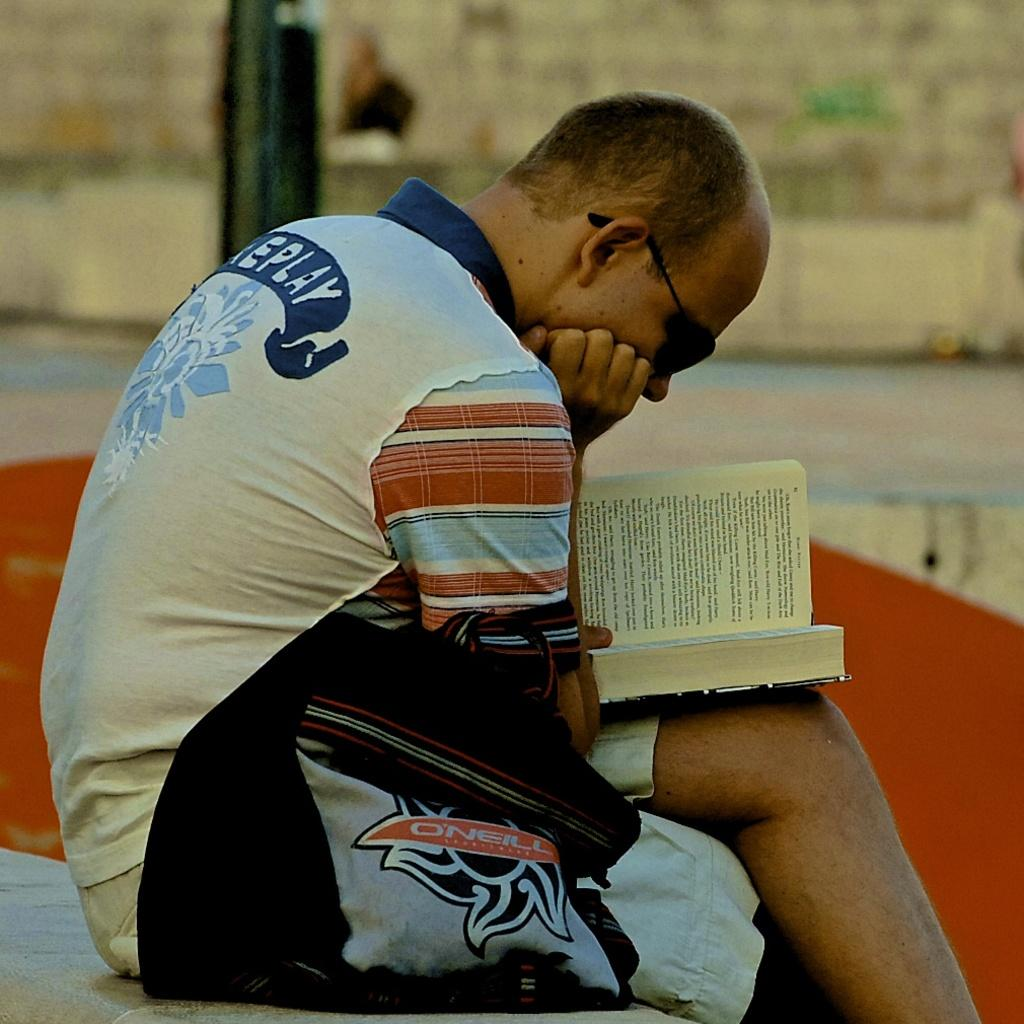What is the main subject of the image? There is a person sitting in the center of the image. What is the person holding in the image? The person is holding a book. What object is located beside the person? There is a bag beside the person. What can be seen in the background of the image? There is a wall, a pole, and the ground visible in the background of the image. What type of grain can be seen growing near the person in the image? There is no grain visible in the image; the background features a wall, a pole, and the ground. Can you tell me how many wrens are perched on the pole in the image? There are no wrens present in the image; the pole is the only object visible on it. 